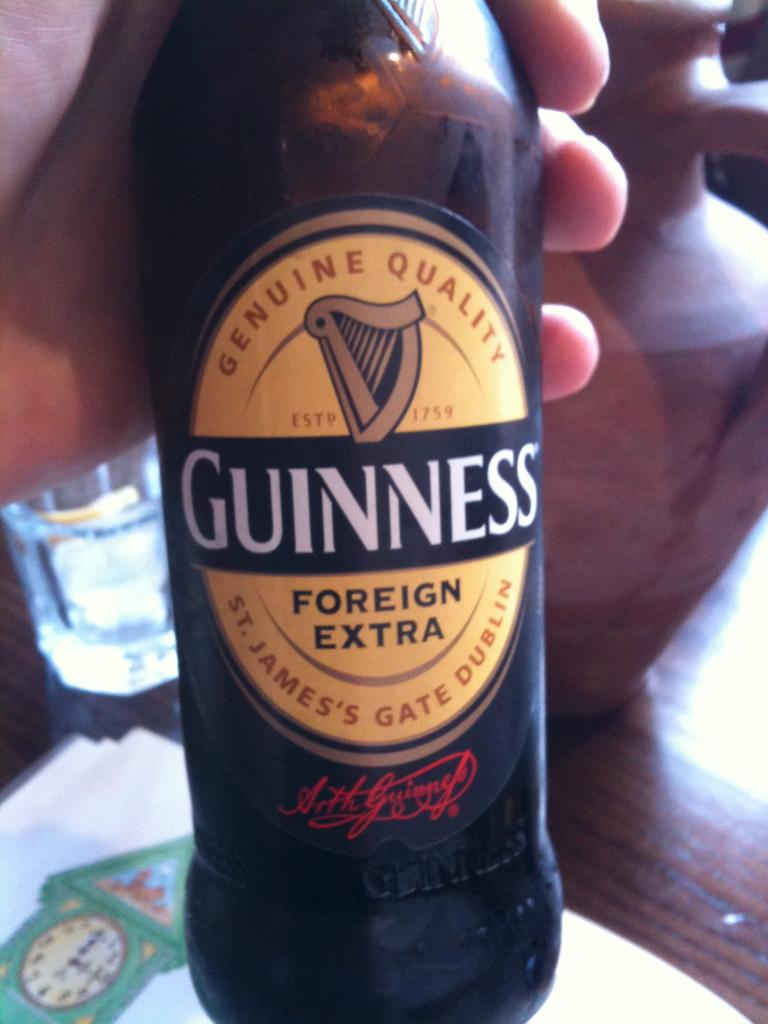<image>
Summarize the visual content of the image. A bottle of Guinness which is from the foreign extra variety. 